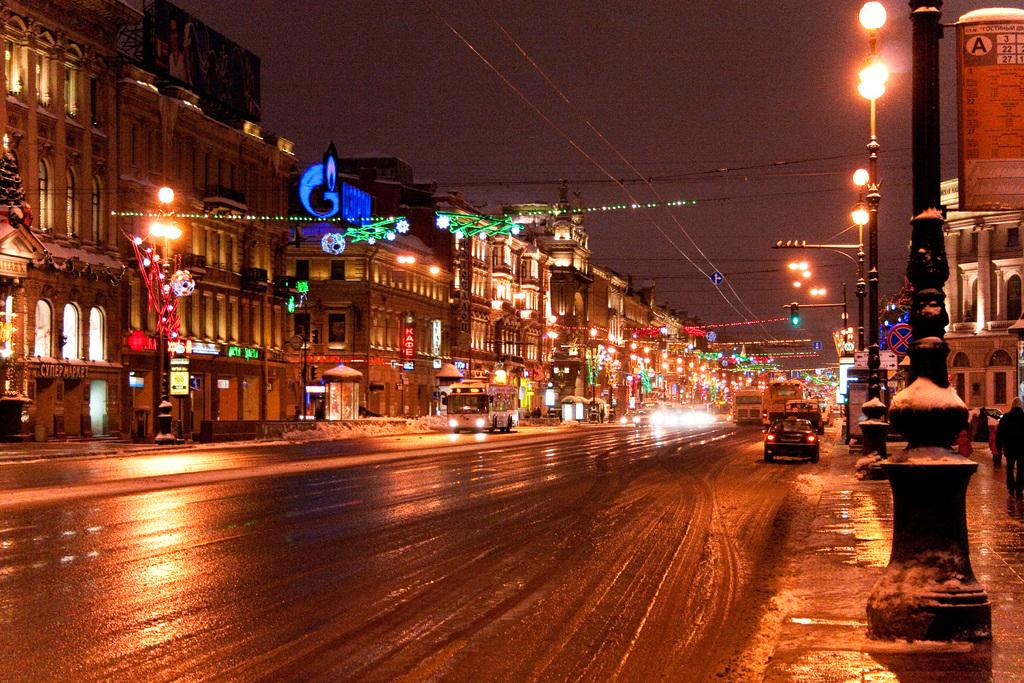What type of structures can be seen in the image? There are buildings in the image. What can be seen attached to the poles in the image? There are lights and wires attached to the poles in the image. What is moving along the road in the image? There are vehicles on the road in the image. What is the time of day depicted in the image? The image is taken during night. What is visible at the top of the image? The sky is visible at the top of the image. What type of food is being served at the kitten's birthday party in the image? There is no kitten or birthday party present in the image. What is the value of the car in the image? The value of the car cannot be determined from the image alone. 